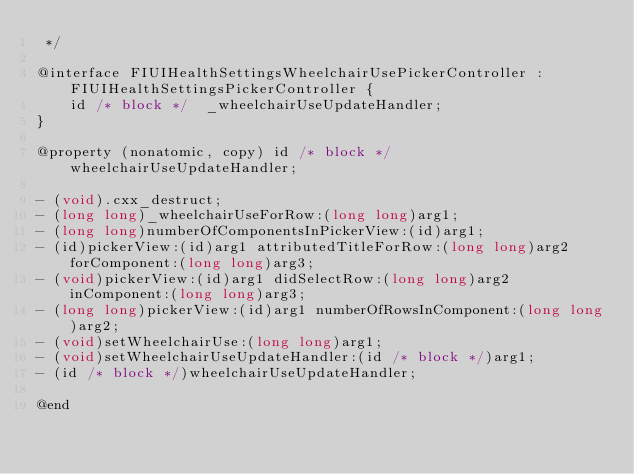<code> <loc_0><loc_0><loc_500><loc_500><_C_> */

@interface FIUIHealthSettingsWheelchairUsePickerController : FIUIHealthSettingsPickerController {
    id /* block */  _wheelchairUseUpdateHandler;
}

@property (nonatomic, copy) id /* block */ wheelchairUseUpdateHandler;

- (void).cxx_destruct;
- (long long)_wheelchairUseForRow:(long long)arg1;
- (long long)numberOfComponentsInPickerView:(id)arg1;
- (id)pickerView:(id)arg1 attributedTitleForRow:(long long)arg2 forComponent:(long long)arg3;
- (void)pickerView:(id)arg1 didSelectRow:(long long)arg2 inComponent:(long long)arg3;
- (long long)pickerView:(id)arg1 numberOfRowsInComponent:(long long)arg2;
- (void)setWheelchairUse:(long long)arg1;
- (void)setWheelchairUseUpdateHandler:(id /* block */)arg1;
- (id /* block */)wheelchairUseUpdateHandler;

@end
</code> 